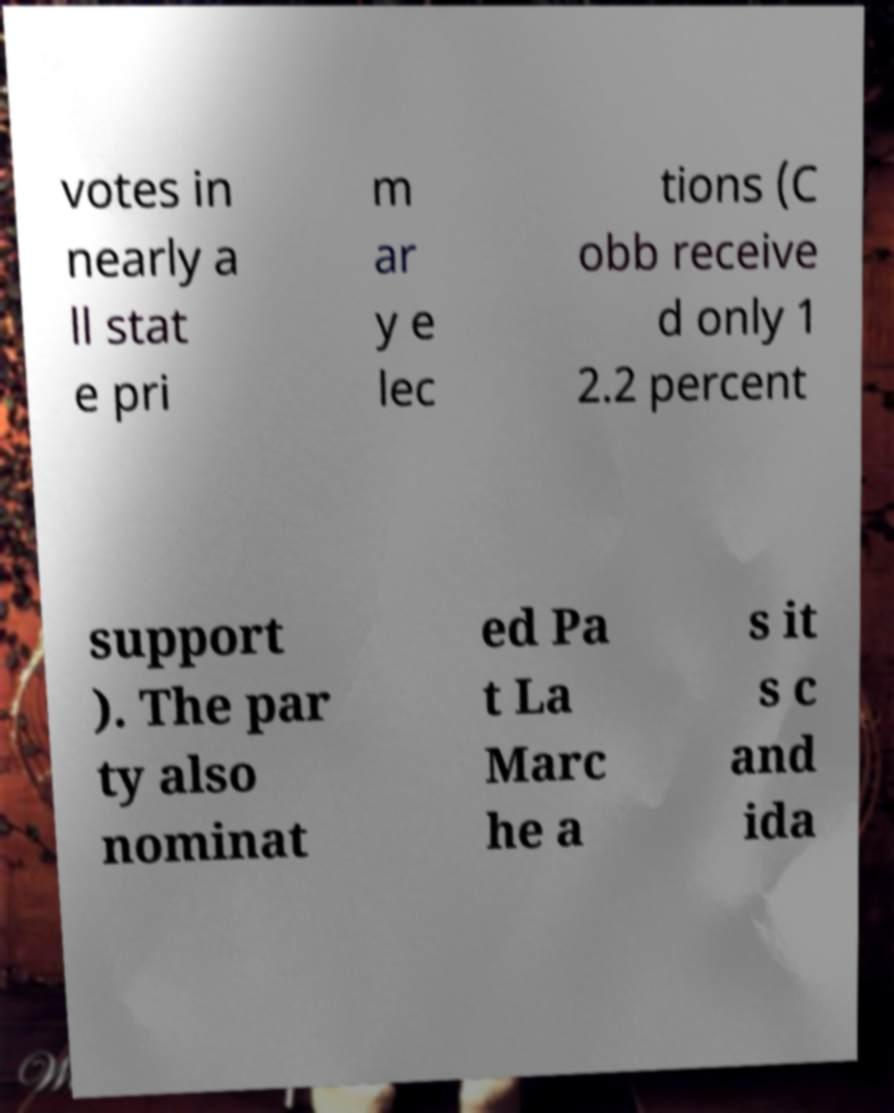Please identify and transcribe the text found in this image. votes in nearly a ll stat e pri m ar y e lec tions (C obb receive d only 1 2.2 percent support ). The par ty also nominat ed Pa t La Marc he a s it s c and ida 